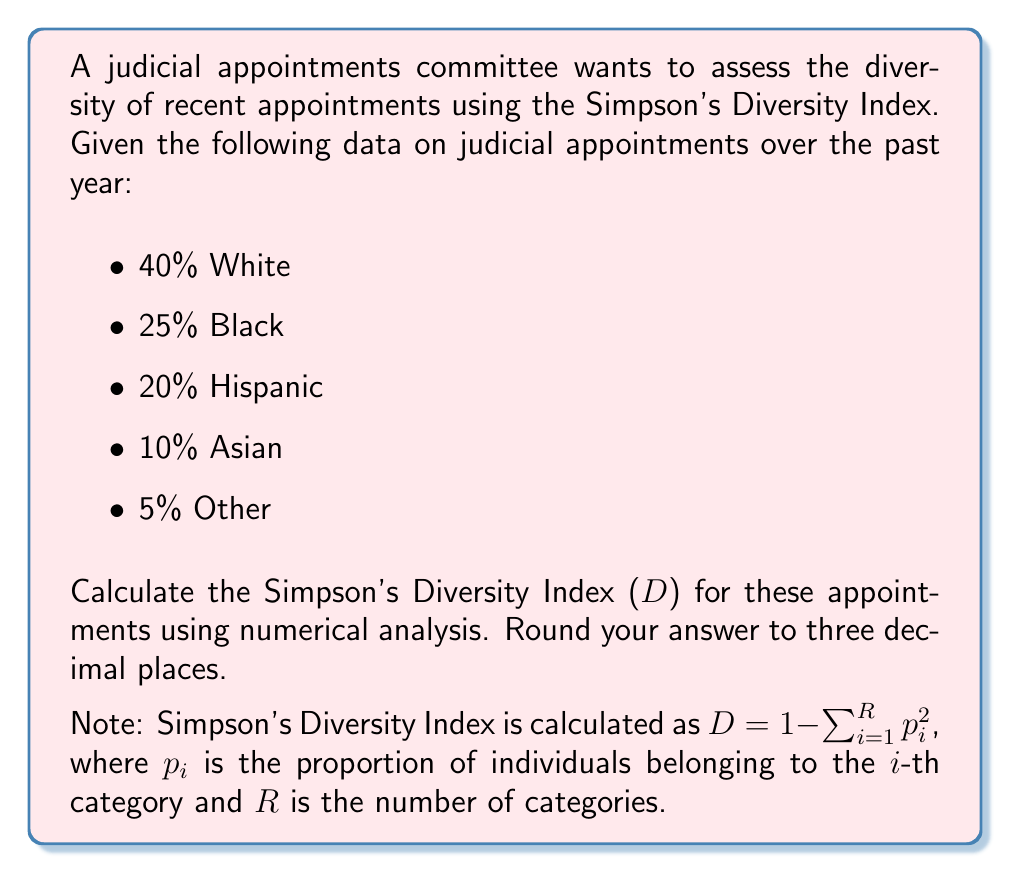Can you solve this math problem? To calculate Simpson's Diversity Index (D), we'll follow these steps:

1. Identify the proportions ($p_i$) for each category:
   $p_1 = 0.40$ (White)
   $p_2 = 0.25$ (Black)
   $p_3 = 0.20$ (Hispanic)
   $p_4 = 0.10$ (Asian)
   $p_5 = 0.05$ (Other)

2. Calculate $p_i^2$ for each category:
   $p_1^2 = 0.40^2 = 0.1600$
   $p_2^2 = 0.25^2 = 0.0625$
   $p_3^2 = 0.20^2 = 0.0400$
   $p_4^2 = 0.10^2 = 0.0100$
   $p_5^2 = 0.05^2 = 0.0025$

3. Sum all $p_i^2$ values:
   $$\sum_{i=1}^{R} p_i^2 = 0.1600 + 0.0625 + 0.0400 + 0.0100 + 0.0025 = 0.2750$$

4. Calculate D using the formula:
   $$D = 1 - \sum_{i=1}^{R} p_i^2 = 1 - 0.2750 = 0.7250$$

5. Round to three decimal places:
   $D \approx 0.725$
Answer: 0.725 